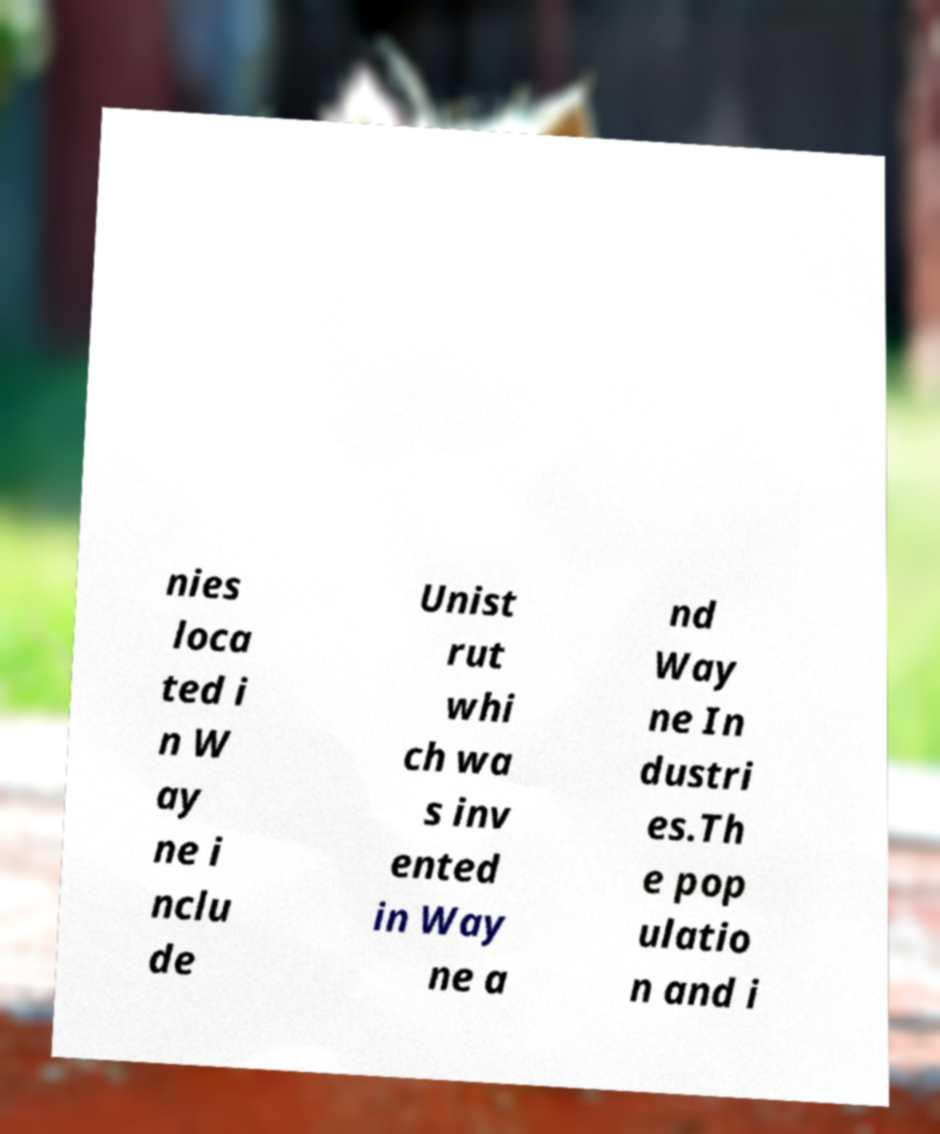Could you assist in decoding the text presented in this image and type it out clearly? nies loca ted i n W ay ne i nclu de Unist rut whi ch wa s inv ented in Way ne a nd Way ne In dustri es.Th e pop ulatio n and i 